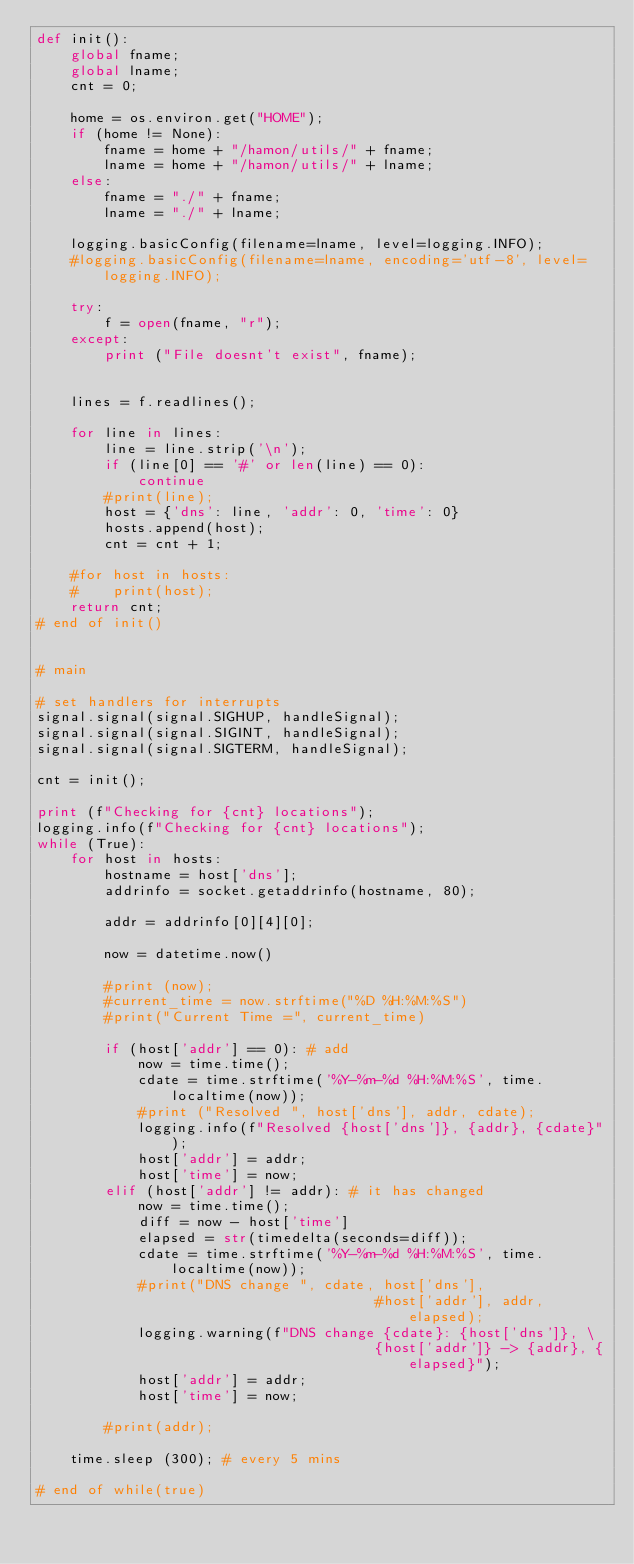<code> <loc_0><loc_0><loc_500><loc_500><_Python_>def init():
    global fname;
    global lname;
    cnt = 0;

    home = os.environ.get("HOME");
    if (home != None):
        fname = home + "/hamon/utils/" + fname;
        lname = home + "/hamon/utils/" + lname;
    else:
        fname = "./" + fname;
        lname = "./" + lname;

    logging.basicConfig(filename=lname, level=logging.INFO);
    #logging.basicConfig(filename=lname, encoding='utf-8', level=logging.INFO);

    try:
        f = open(fname, "r");
    except:
        print ("File doesnt't exist", fname);


    lines = f.readlines();

    for line in lines:
        line = line.strip('\n');
        if (line[0] == '#' or len(line) == 0):
            continue
        #print(line);
        host = {'dns': line, 'addr': 0, 'time': 0}
        hosts.append(host);
        cnt = cnt + 1;

    #for host in hosts:
    #    print(host);
    return cnt;
# end of init()


# main

# set handlers for interrupts
signal.signal(signal.SIGHUP, handleSignal);
signal.signal(signal.SIGINT, handleSignal);
signal.signal(signal.SIGTERM, handleSignal);

cnt = init();

print (f"Checking for {cnt} locations");
logging.info(f"Checking for {cnt} locations");
while (True):
    for host in hosts:
        hostname = host['dns'];
        addrinfo = socket.getaddrinfo(hostname, 80);

        addr = addrinfo[0][4][0];
       
        now = datetime.now()

        #print (now);
        #current_time = now.strftime("%D %H:%M:%S")
        #print("Current Time =", current_time)

        if (host['addr'] == 0): # add
            now = time.time();
            cdate = time.strftime('%Y-%m-%d %H:%M:%S', time.localtime(now));
            #print ("Resolved ", host['dns'], addr, cdate);
            logging.info(f"Resolved {host['dns']}, {addr}, {cdate}");
            host['addr'] = addr;
            host['time'] = now;
        elif (host['addr'] != addr): # it has changed
            now = time.time();
            diff = now - host['time']
            elapsed = str(timedelta(seconds=diff));
            cdate = time.strftime('%Y-%m-%d %H:%M:%S', time.localtime(now));
            #print("DNS change ", cdate, host['dns'],
                                        #host['addr'], addr, elapsed);
            logging.warning(f"DNS change {cdate}: {host['dns']}, \
                                        {host['addr']} -> {addr}, {elapsed}");
            host['addr'] = addr;
            host['time'] = now;

        #print(addr);

    time.sleep (300); # every 5 mins

# end of while(true)
</code> 